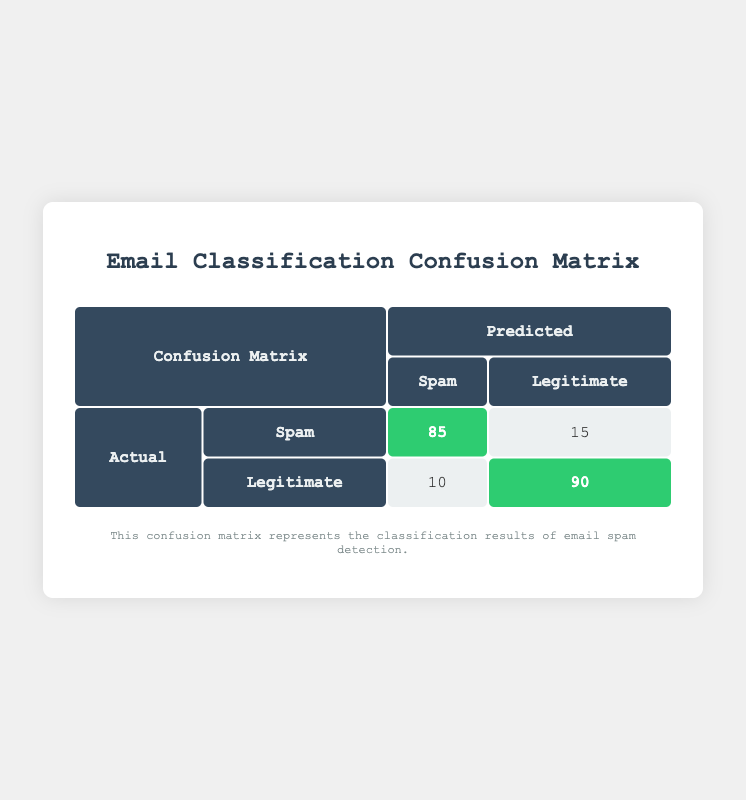What is the total number of emails classified as Spam? To find the total number of emails classified as Spam, we sum the predicted Spam counts for both actual Spam and Legitimate messages. This is calculated as 85 (actual Spam predicted as Spam) + 10 (actual Legitimate predicted as Spam) = 95.
Answer: 95 What is the total number of emails classified as Legitimate? To find the total number of emails classified as Legitimate, we sum the predicted Legitimate counts for both actual Spam and Legitimate messages. This is calculated as 15 (actual Spam predicted as Legitimate) + 90 (actual Legitimate predicted as Legitimate) = 105.
Answer: 105 How many emails were incorrectly classified as Spam? Emails incorrectly classified as Spam are those that were actually Legitimate but predicted as Spam. This is counted as 10.
Answer: 10 What percentage of actual Spam emails were correctly classified? To find the percentage of correctly classified actual Spam emails, we take the number of correctly predicted Spam emails (85) and divide it by the total number of actual Spam emails (85 + 15 = 100). The calculation is (85/100) * 100 = 85%.
Answer: 85% Is the number of legitimate emails predicted as Spam greater than the number of spam emails predicted as Legitimate? We compare the counts: 10 (Legitimate predicted as Spam) and 15 (Spam predicted as Legitimate). Since 10 is less than 15, the statement is false.
Answer: No What is the overall accuracy of the email classification? Overall accuracy is calculated by adding the count of correct predictions (both Spam and Legitimate) and dividing by the total number of emails. The number of correct predictions is 85 (Spam) + 90 (Legitimate) = 175, with a total of 100 (Spam + Legitimate) + 100 = 200 emails. The calculation is (175/200) * 100 = 87.5%.
Answer: 87.5% How many total emails were analyzed in this classification? To find the total number of emails analyzed, we sum all counts across Spam and Legitimate predictions: 85 (Spam as Spam) + 15 (Spam as Legitimate) + 10 (Legitimate as Spam) + 90 (Legitimate as Legitimate) = 200.
Answer: 200 What is the difference between the number of correctly classified Legitimate emails and incorrectly classified Legitimate emails? The number of correctly classified Legitimate emails is 90, while the incorrectly classified Legitimate emails is 10. The difference is computed as 90 - 10 = 80.
Answer: 80 What proportion of total emails was classified as Spam? To find the proportion of total emails classified as Spam, we take the total classified Spam (95) and divide it by the total number of emails (200). The calculation is 95/200 = 0.475, which is 47.5%.
Answer: 47.5% 